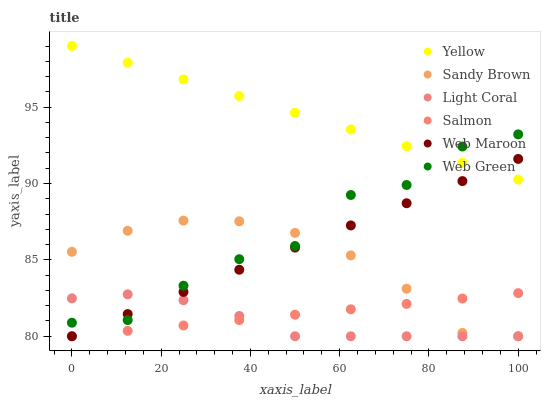Does Light Coral have the minimum area under the curve?
Answer yes or no. Yes. Does Yellow have the maximum area under the curve?
Answer yes or no. Yes. Does Salmon have the minimum area under the curve?
Answer yes or no. No. Does Salmon have the maximum area under the curve?
Answer yes or no. No. Is Yellow the smoothest?
Answer yes or no. Yes. Is Web Green the roughest?
Answer yes or no. Yes. Is Salmon the smoothest?
Answer yes or no. No. Is Salmon the roughest?
Answer yes or no. No. Does Web Maroon have the lowest value?
Answer yes or no. Yes. Does Web Green have the lowest value?
Answer yes or no. No. Does Yellow have the highest value?
Answer yes or no. Yes. Does Salmon have the highest value?
Answer yes or no. No. Is Salmon less than Web Green?
Answer yes or no. Yes. Is Yellow greater than Salmon?
Answer yes or no. Yes. Does Light Coral intersect Salmon?
Answer yes or no. Yes. Is Light Coral less than Salmon?
Answer yes or no. No. Is Light Coral greater than Salmon?
Answer yes or no. No. Does Salmon intersect Web Green?
Answer yes or no. No. 